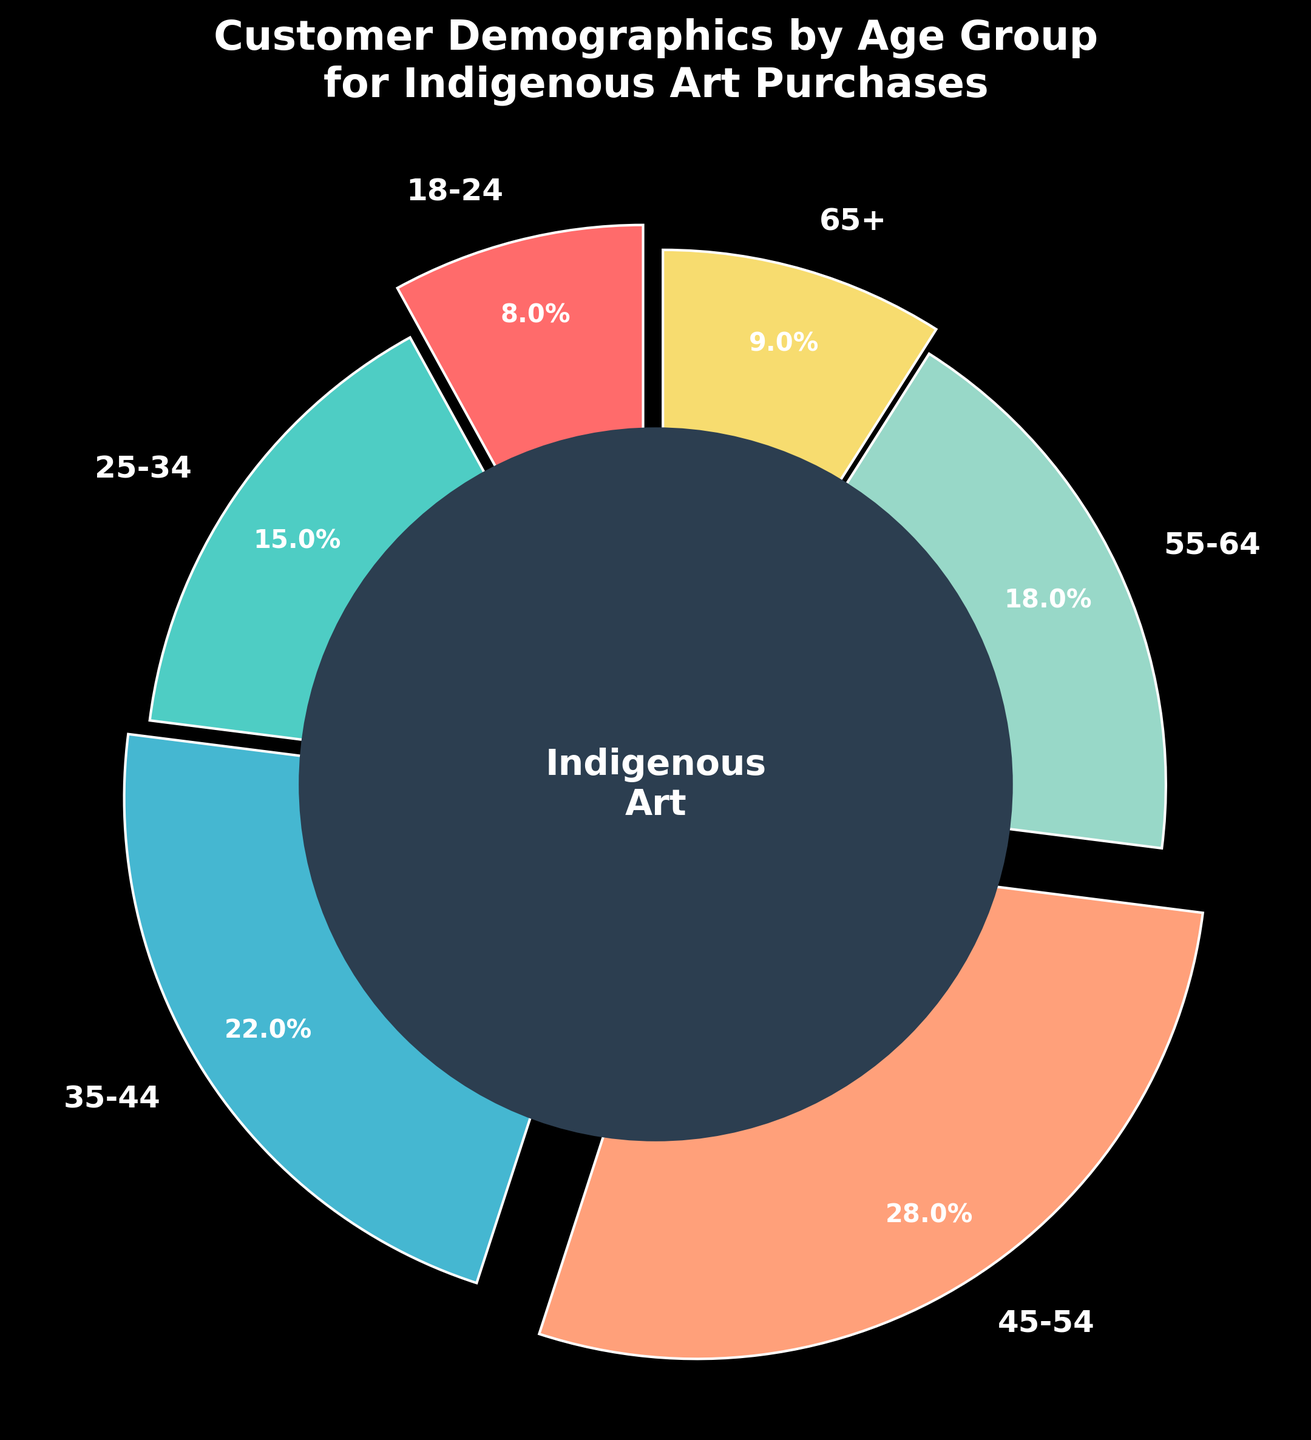What age group makes up the largest percentage of customers? The figure shows that the '45-54' age group has the largest slice of the pie chart with 28%.
Answer: 45-54 Which age group has the smallest percentage of customers? The figure shows that the '18-24' age group has the smallest slice of the pie chart with 8%.
Answer: 18-24 How much higher is the percentage of customers aged 55-64 compared to those aged 65+? The percentage for the 55-64 age group is 18% while for the 65+ group it is 9%. The difference is 18% - 9% = 9%.
Answer: 9% Sum the percentages of customers aged 25-34 and 35-44. The percentage for the 25-34 age group is 15% and for the 35-44 age group is 22%. Summing them up gives 15% + 22% = 37%.
Answer: 37% Which age groups have a percentage close to the average percentage of all age groups? The total percentage is 100%. There are 6 age groups, so the average percentage is 100% / 6 ≈ 16.67%. The age groups 55-64 and 25-34 are closest to this average with percentages of 18% and 15%, respectively.
Answer: 55-64 and 25-34 Compare the combined percentage of the youngest (18-24) and oldest (65+) age groups against the 35-44 age group. The combined percentage for the 18-24 and 65+ groups is 8% + 9% = 17%. The percentage for the 35-44 group is 22%. Hence, the combined percentage (17%) is less than the 35-44 age group's percentage (22%).
Answer: Less Which age group is represented by the blue color in the chart? Observing the colors assigned to each age group, the blue color corresponds to the '35-44' age group.
Answer: 35-44 Calculate the difference in percentage between the age groups 45-54 and 25-34. The percentage for the 45-54 age group is 28% and for the 25-34 age group, it is 15%. The difference between them is 28% - 15% = 13%.
Answer: 13% What is the total percentage of customers within the age range of 35-54? The percentages for the age groups 35-44 and 45-54 are 22% and 28% respectively. Summing them up gives 22% + 28% = 50%.
Answer: 50% Which age group has the third-largest slice of the pie chart? From the figure, the age group '55-64' has the third-largest slice with 18%, after the groups 45-54 (28%) and 35-44 (22%).
Answer: 55-64 